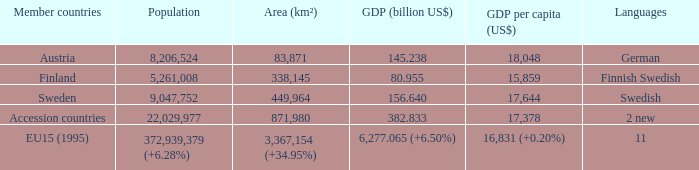Determine the territory linked to germany. 83871.0. 